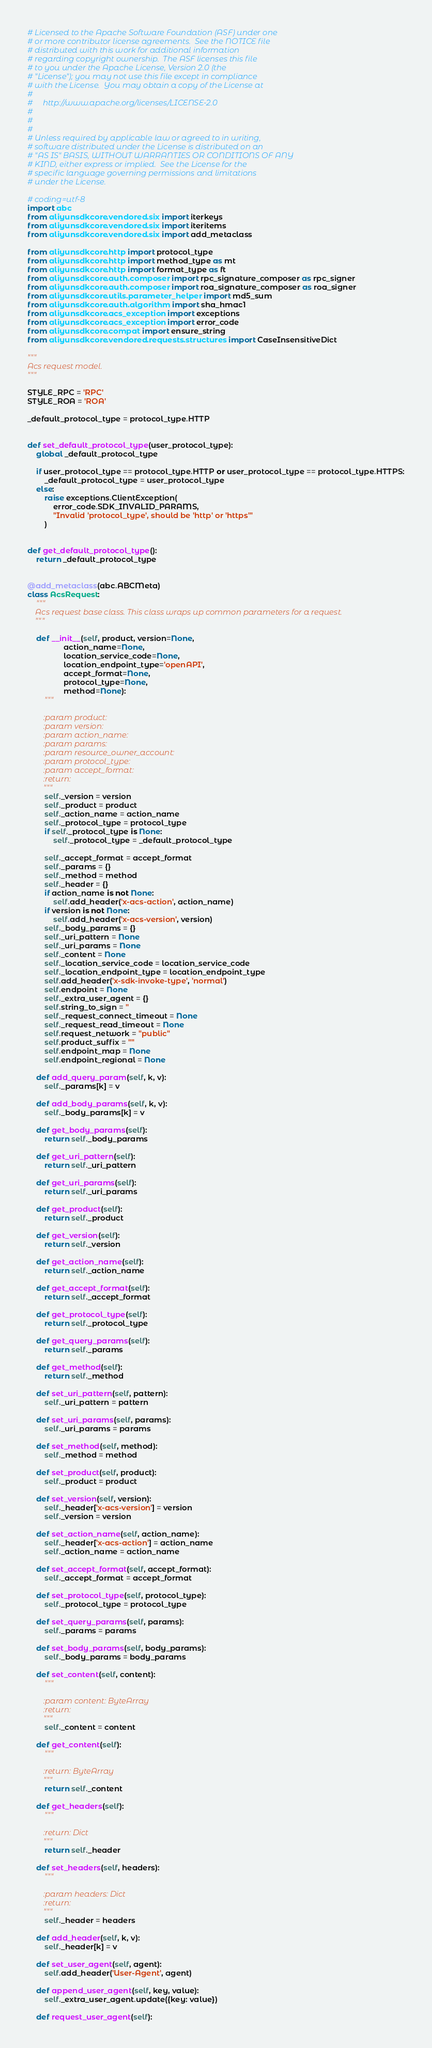Convert code to text. <code><loc_0><loc_0><loc_500><loc_500><_Python_># Licensed to the Apache Software Foundation (ASF) under one
# or more contributor license agreements.  See the NOTICE file
# distributed with this work for additional information
# regarding copyright ownership.  The ASF licenses this file
# to you under the Apache License, Version 2.0 (the
# "License"); you may not use this file except in compliance
# with the License.  You may obtain a copy of the License at
#
#     http://www.apache.org/licenses/LICENSE-2.0
#
#
#
# Unless required by applicable law or agreed to in writing,
# software distributed under the License is distributed on an
# "AS IS" BASIS, WITHOUT WARRANTIES OR CONDITIONS OF ANY
# KIND, either express or implied.  See the License for the
# specific language governing permissions and limitations
# under the License.

# coding=utf-8
import abc
from aliyunsdkcore.vendored.six import iterkeys
from aliyunsdkcore.vendored.six import iteritems
from aliyunsdkcore.vendored.six import add_metaclass

from aliyunsdkcore.http import protocol_type
from aliyunsdkcore.http import method_type as mt
from aliyunsdkcore.http import format_type as ft
from aliyunsdkcore.auth.composer import rpc_signature_composer as rpc_signer
from aliyunsdkcore.auth.composer import roa_signature_composer as roa_signer
from aliyunsdkcore.utils.parameter_helper import md5_sum
from aliyunsdkcore.auth.algorithm import sha_hmac1
from aliyunsdkcore.acs_exception import exceptions
from aliyunsdkcore.acs_exception import error_code
from aliyunsdkcore.compat import ensure_string
from aliyunsdkcore.vendored.requests.structures import CaseInsensitiveDict

"""
Acs request model.
"""

STYLE_RPC = 'RPC'
STYLE_ROA = 'ROA'

_default_protocol_type = protocol_type.HTTP


def set_default_protocol_type(user_protocol_type):
    global _default_protocol_type

    if user_protocol_type == protocol_type.HTTP or user_protocol_type == protocol_type.HTTPS:
        _default_protocol_type = user_protocol_type
    else:
        raise exceptions.ClientException(
            error_code.SDK_INVALID_PARAMS,
            "Invalid 'protocol_type', should be 'http' or 'https'"
        )


def get_default_protocol_type():
    return _default_protocol_type


@add_metaclass(abc.ABCMeta)
class AcsRequest:
    """
    Acs request base class. This class wraps up common parameters for a request.
    """

    def __init__(self, product, version=None,
                 action_name=None,
                 location_service_code=None,
                 location_endpoint_type='openAPI',
                 accept_format=None,
                 protocol_type=None,
                 method=None):
        """

        :param product:
        :param version:
        :param action_name:
        :param params:
        :param resource_owner_account:
        :param protocol_type:
        :param accept_format:
        :return:
        """
        self._version = version
        self._product = product
        self._action_name = action_name
        self._protocol_type = protocol_type
        if self._protocol_type is None:
            self._protocol_type = _default_protocol_type

        self._accept_format = accept_format
        self._params = {}
        self._method = method
        self._header = {}
        if action_name is not None:
            self.add_header('x-acs-action', action_name)
        if version is not None:
            self.add_header('x-acs-version', version)
        self._body_params = {}
        self._uri_pattern = None
        self._uri_params = None
        self._content = None
        self._location_service_code = location_service_code
        self._location_endpoint_type = location_endpoint_type
        self.add_header('x-sdk-invoke-type', 'normal')
        self.endpoint = None
        self._extra_user_agent = {}
        self.string_to_sign = ''
        self._request_connect_timeout = None
        self._request_read_timeout = None
        self.request_network = "public"
        self.product_suffix = ""
        self.endpoint_map = None
        self.endpoint_regional = None

    def add_query_param(self, k, v):
        self._params[k] = v

    def add_body_params(self, k, v):
        self._body_params[k] = v

    def get_body_params(self):
        return self._body_params

    def get_uri_pattern(self):
        return self._uri_pattern

    def get_uri_params(self):
        return self._uri_params

    def get_product(self):
        return self._product

    def get_version(self):
        return self._version

    def get_action_name(self):
        return self._action_name

    def get_accept_format(self):
        return self._accept_format

    def get_protocol_type(self):
        return self._protocol_type

    def get_query_params(self):
        return self._params

    def get_method(self):
        return self._method

    def set_uri_pattern(self, pattern):
        self._uri_pattern = pattern

    def set_uri_params(self, params):
        self._uri_params = params

    def set_method(self, method):
        self._method = method

    def set_product(self, product):
        self._product = product

    def set_version(self, version):
        self._header['x-acs-version'] = version
        self._version = version

    def set_action_name(self, action_name):
        self._header['x-acs-action'] = action_name
        self._action_name = action_name

    def set_accept_format(self, accept_format):
        self._accept_format = accept_format

    def set_protocol_type(self, protocol_type):
        self._protocol_type = protocol_type

    def set_query_params(self, params):
        self._params = params

    def set_body_params(self, body_params):
        self._body_params = body_params

    def set_content(self, content):
        """

        :param content: ByteArray
        :return:
        """
        self._content = content

    def get_content(self):
        """

        :return: ByteArray
        """
        return self._content

    def get_headers(self):
        """

        :return: Dict
        """
        return self._header

    def set_headers(self, headers):
        """

        :param headers: Dict
        :return:
        """
        self._header = headers

    def add_header(self, k, v):
        self._header[k] = v

    def set_user_agent(self, agent):
        self.add_header('User-Agent', agent)

    def append_user_agent(self, key, value):
        self._extra_user_agent.update({key: value})

    def request_user_agent(self):</code> 